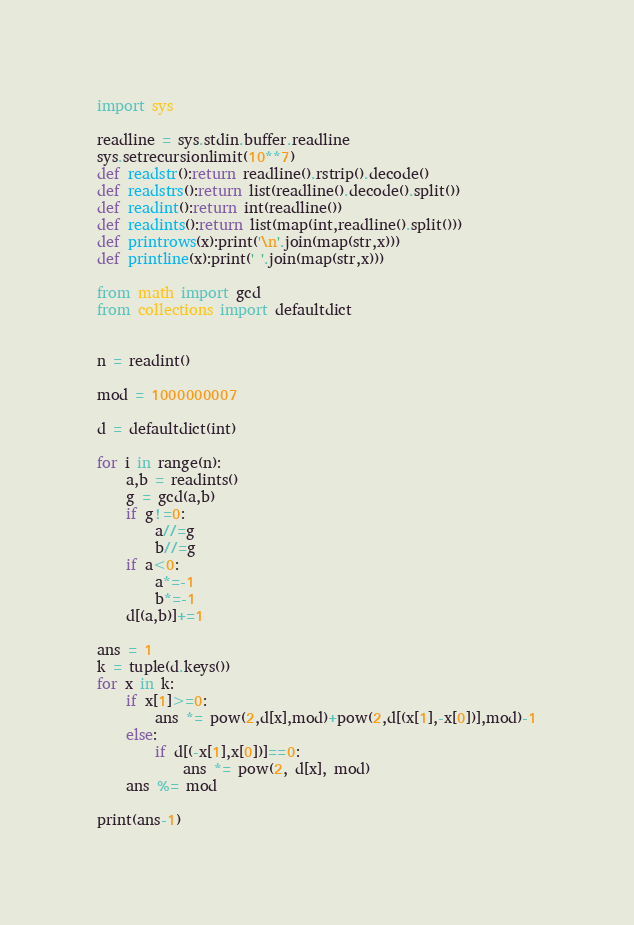Convert code to text. <code><loc_0><loc_0><loc_500><loc_500><_Python_>import sys

readline = sys.stdin.buffer.readline
sys.setrecursionlimit(10**7)
def readstr():return readline().rstrip().decode()
def readstrs():return list(readline().decode().split())
def readint():return int(readline())
def readints():return list(map(int,readline().split()))
def printrows(x):print('\n'.join(map(str,x)))
def printline(x):print(' '.join(map(str,x)))

from math import gcd
from collections import defaultdict


n = readint()

mod = 1000000007

d = defaultdict(int)

for i in range(n):
    a,b = readints()
    g = gcd(a,b)
    if g!=0:
        a//=g
        b//=g
    if a<0:
        a*=-1
        b*=-1
    d[(a,b)]+=1

ans = 1
k = tuple(d.keys())
for x in k:
    if x[1]>=0:
        ans *= pow(2,d[x],mod)+pow(2,d[(x[1],-x[0])],mod)-1
    else:
        if d[(-x[1],x[0])]==0:
            ans *= pow(2, d[x], mod)
    ans %= mod

print(ans-1)




</code> 